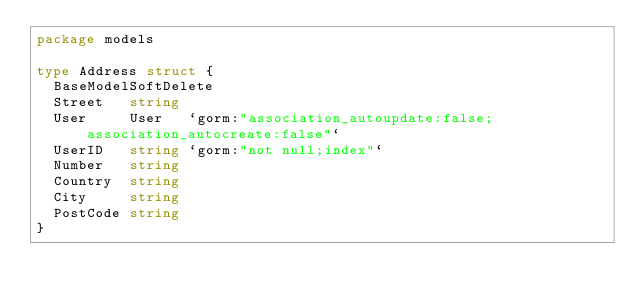Convert code to text. <code><loc_0><loc_0><loc_500><loc_500><_Go_>package models

type Address struct {
	BaseModelSoftDelete
	Street   string
	User     User   `gorm:"association_autoupdate:false;association_autocreate:false"`
	UserID   string `gorm:"not null;index"`
	Number   string
	Country  string
	City     string
	PostCode string
}
</code> 